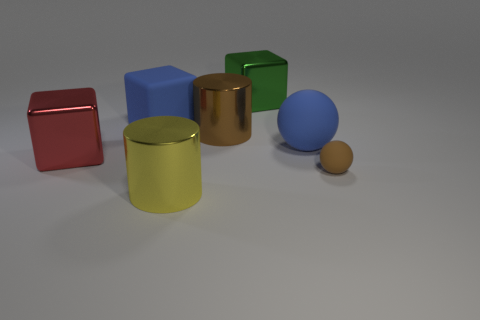What number of brown rubber spheres are in front of the big red metal block?
Give a very brief answer. 1. There is a large blue thing behind the blue matte object that is to the right of the brown metallic cylinder; is there a large shiny thing behind it?
Ensure brevity in your answer.  Yes. How many things have the same size as the brown rubber ball?
Keep it short and to the point. 0. What material is the brown thing to the left of the matte sphere in front of the large red thing made of?
Offer a terse response. Metal. The blue thing that is on the left side of the large cylinder that is in front of the large metallic block that is on the left side of the big green object is what shape?
Make the answer very short. Cube. Is the shape of the blue object in front of the big blue rubber cube the same as the large blue rubber thing that is on the left side of the big yellow cylinder?
Your response must be concise. No. How many other things are there of the same material as the blue cube?
Provide a short and direct response. 2. What is the shape of the big green thing that is made of the same material as the yellow cylinder?
Provide a short and direct response. Cube. Is the green metallic block the same size as the yellow metal cylinder?
Make the answer very short. Yes. What is the size of the brown sphere in front of the metallic cylinder that is behind the small brown rubber ball?
Offer a very short reply. Small. 